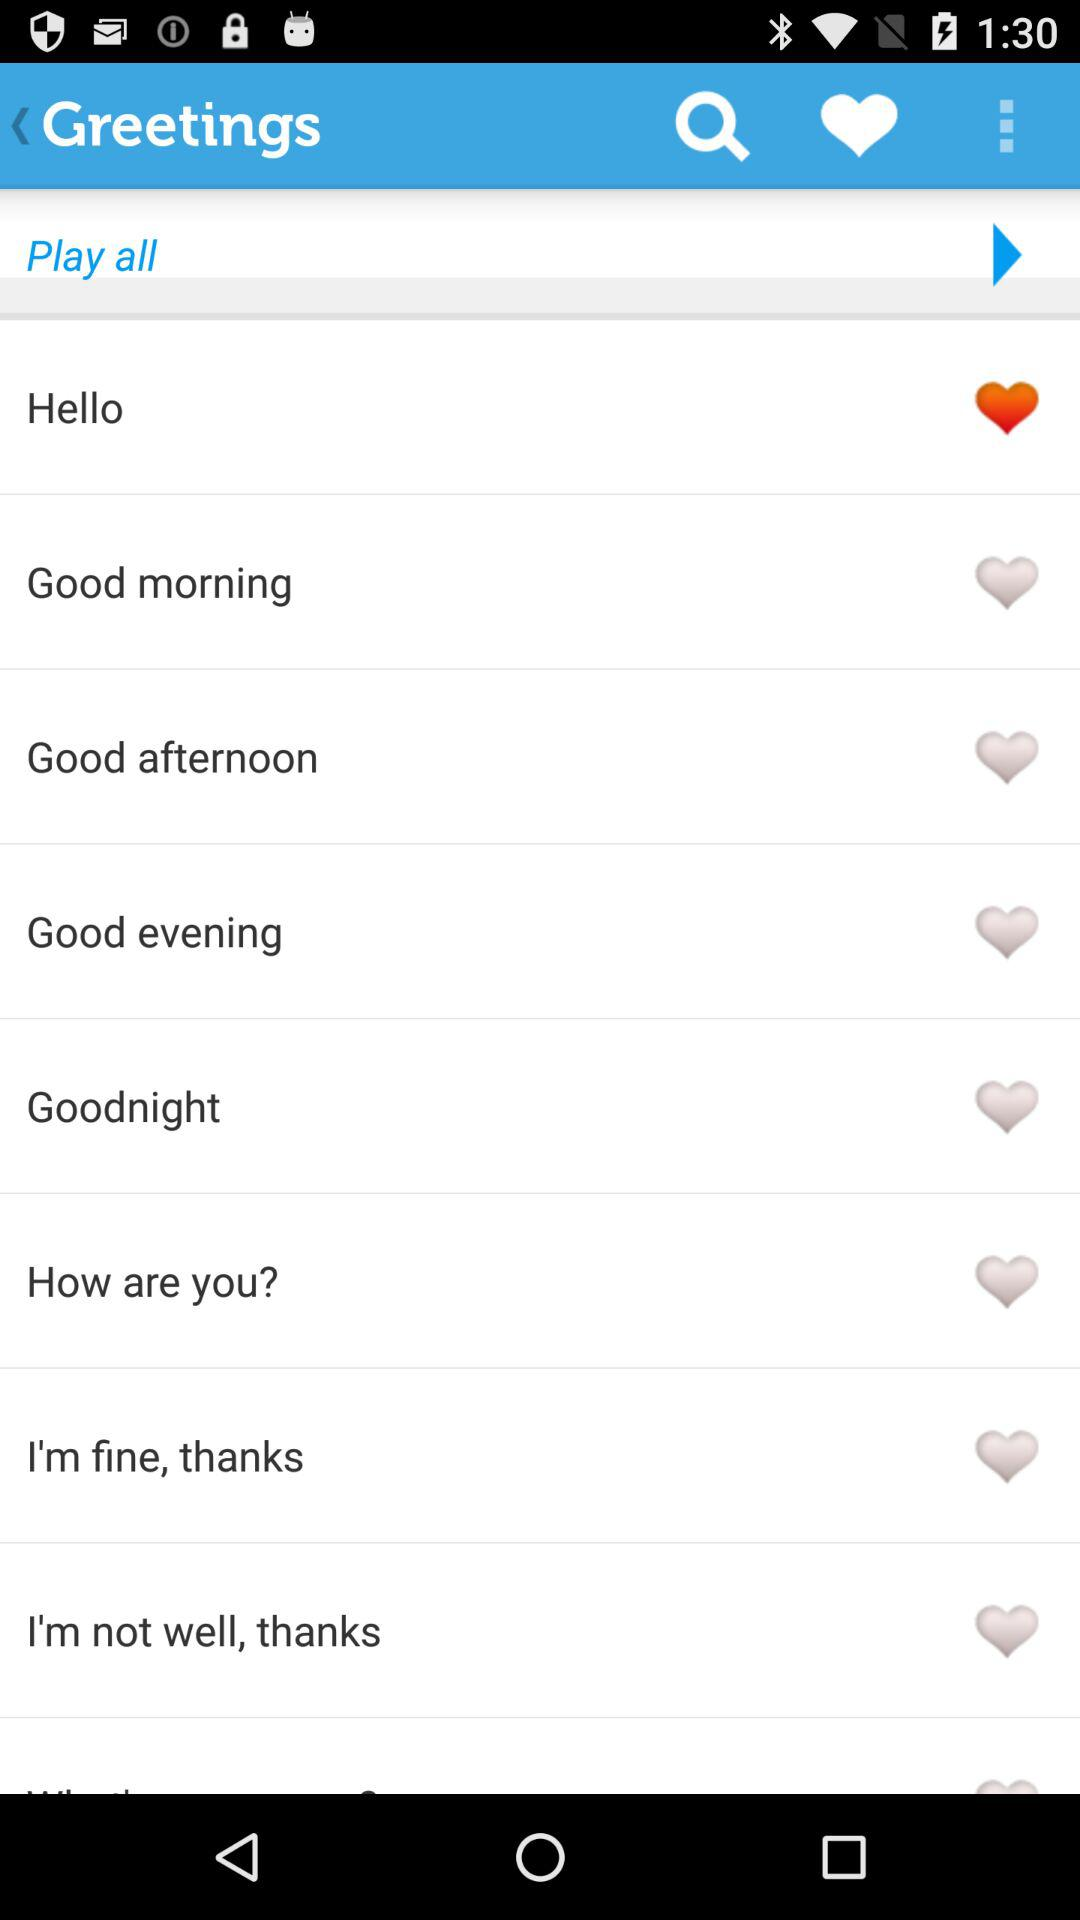What are the different available greeting options? The different available greeting options are "Hello", "Good morning", "Good afternoon", "Good evening", "Goodnight", "How are you?", "I'm fine, thanks" and "I'm not well, thanks". 